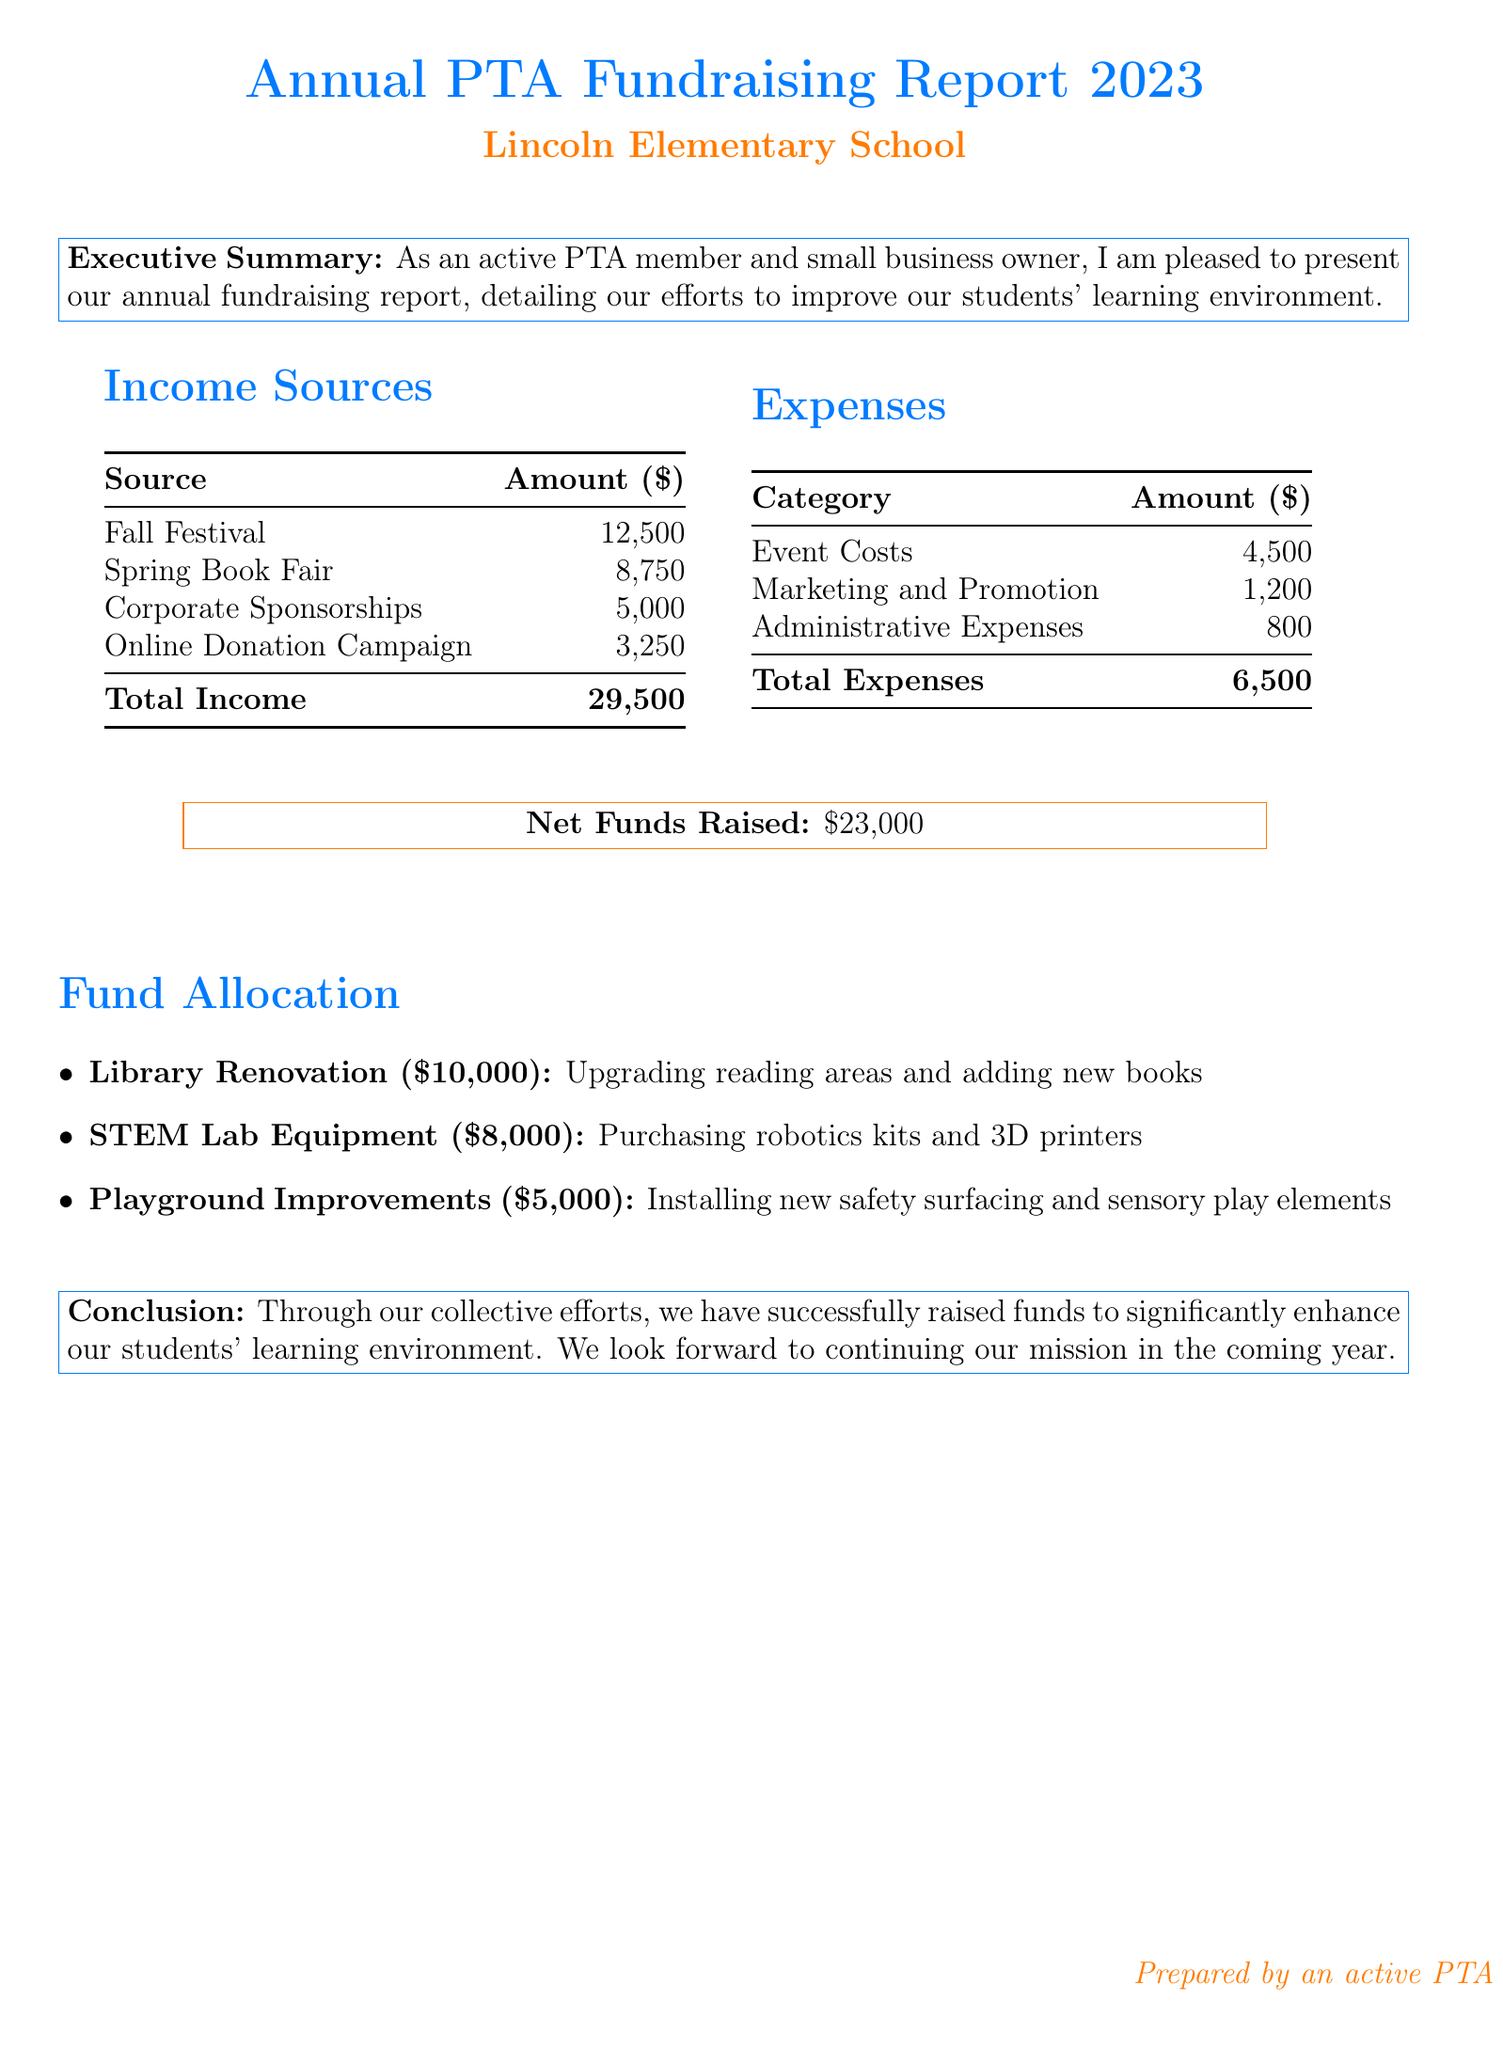what is the total income? The total income is the sum of all income sources listed in the document, which totals to 12,500 + 8,750 + 5,000 + 3,250.
Answer: 29,500 what is the amount allocated for Library Renovation? The document states that $10,000 is allocated for Library Renovation to upgrade reading areas and add new books.
Answer: 10,000 what are the three sources of income listed? The sources of income mentioned are Fall Festival, Spring Book Fair, and Corporate Sponsorships.
Answer: Fall Festival, Spring Book Fair, Corporate Sponsorships how much was spent on Marketing and Promotion? The document indicates that expenses for Marketing and Promotion amount to $1,200.
Answer: 1,200 what is the net funds raised? The net funds raised is calculated as total income minus total expenses, which is 29,500 - 6,500.
Answer: 23,000 which project received the most funding? The Library Renovation project received the most funding of $10,000.
Answer: Library Renovation what percentage of total income is spent on expenses? The percentage of total income spent on expenses can be calculated as (total expenses / total income) * 100, which is (6,500 / 29,500) * 100.
Answer: 22.03 how many fundraising events are listed as income sources? There are four fundraising events listed as income sources in the document.
Answer: 4 what is the total amount allocated for Playground Improvements? The document states that $5,000 is allocated for Playground Improvements for installing new safety surfacing and sensory play elements.
Answer: 5,000 what is the conclusion of the report? The report concludes that fundraising efforts have successfully raised funds to enhance the students' learning environment and expresses a commitment to continue in the future.
Answer: We look forward to continuing our mission in the coming year 